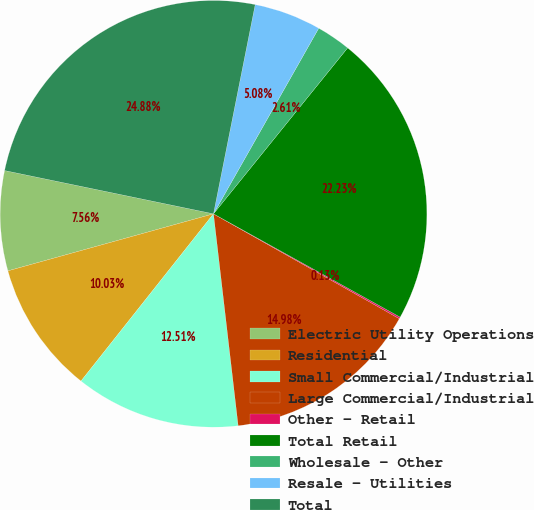Convert chart to OTSL. <chart><loc_0><loc_0><loc_500><loc_500><pie_chart><fcel>Electric Utility Operations<fcel>Residential<fcel>Small Commercial/Industrial<fcel>Large Commercial/Industrial<fcel>Other - Retail<fcel>Total Retail<fcel>Wholesale - Other<fcel>Resale - Utilities<fcel>Total<nl><fcel>7.56%<fcel>10.03%<fcel>12.51%<fcel>14.98%<fcel>0.13%<fcel>22.23%<fcel>2.61%<fcel>5.08%<fcel>24.88%<nl></chart> 